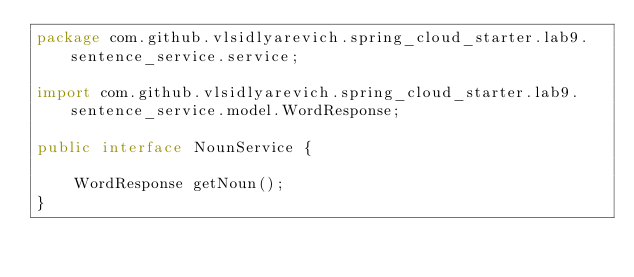Convert code to text. <code><loc_0><loc_0><loc_500><loc_500><_Java_>package com.github.vlsidlyarevich.spring_cloud_starter.lab9.sentence_service.service;

import com.github.vlsidlyarevich.spring_cloud_starter.lab9.sentence_service.model.WordResponse;

public interface NounService {

    WordResponse getNoun();
}
</code> 